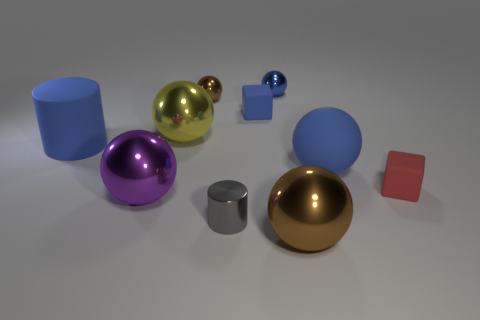Subtract all tiny blue spheres. How many spheres are left? 5 Subtract all blue blocks. How many brown balls are left? 2 Subtract 1 balls. How many balls are left? 5 Subtract all yellow spheres. How many spheres are left? 5 Subtract all cylinders. Subtract all green matte cylinders. How many objects are left? 8 Add 6 small blue metallic things. How many small blue metallic things are left? 7 Add 2 large yellow matte objects. How many large yellow matte objects exist? 2 Subtract 0 purple cylinders. How many objects are left? 10 Subtract all blocks. How many objects are left? 8 Subtract all red cubes. Subtract all purple cylinders. How many cubes are left? 1 